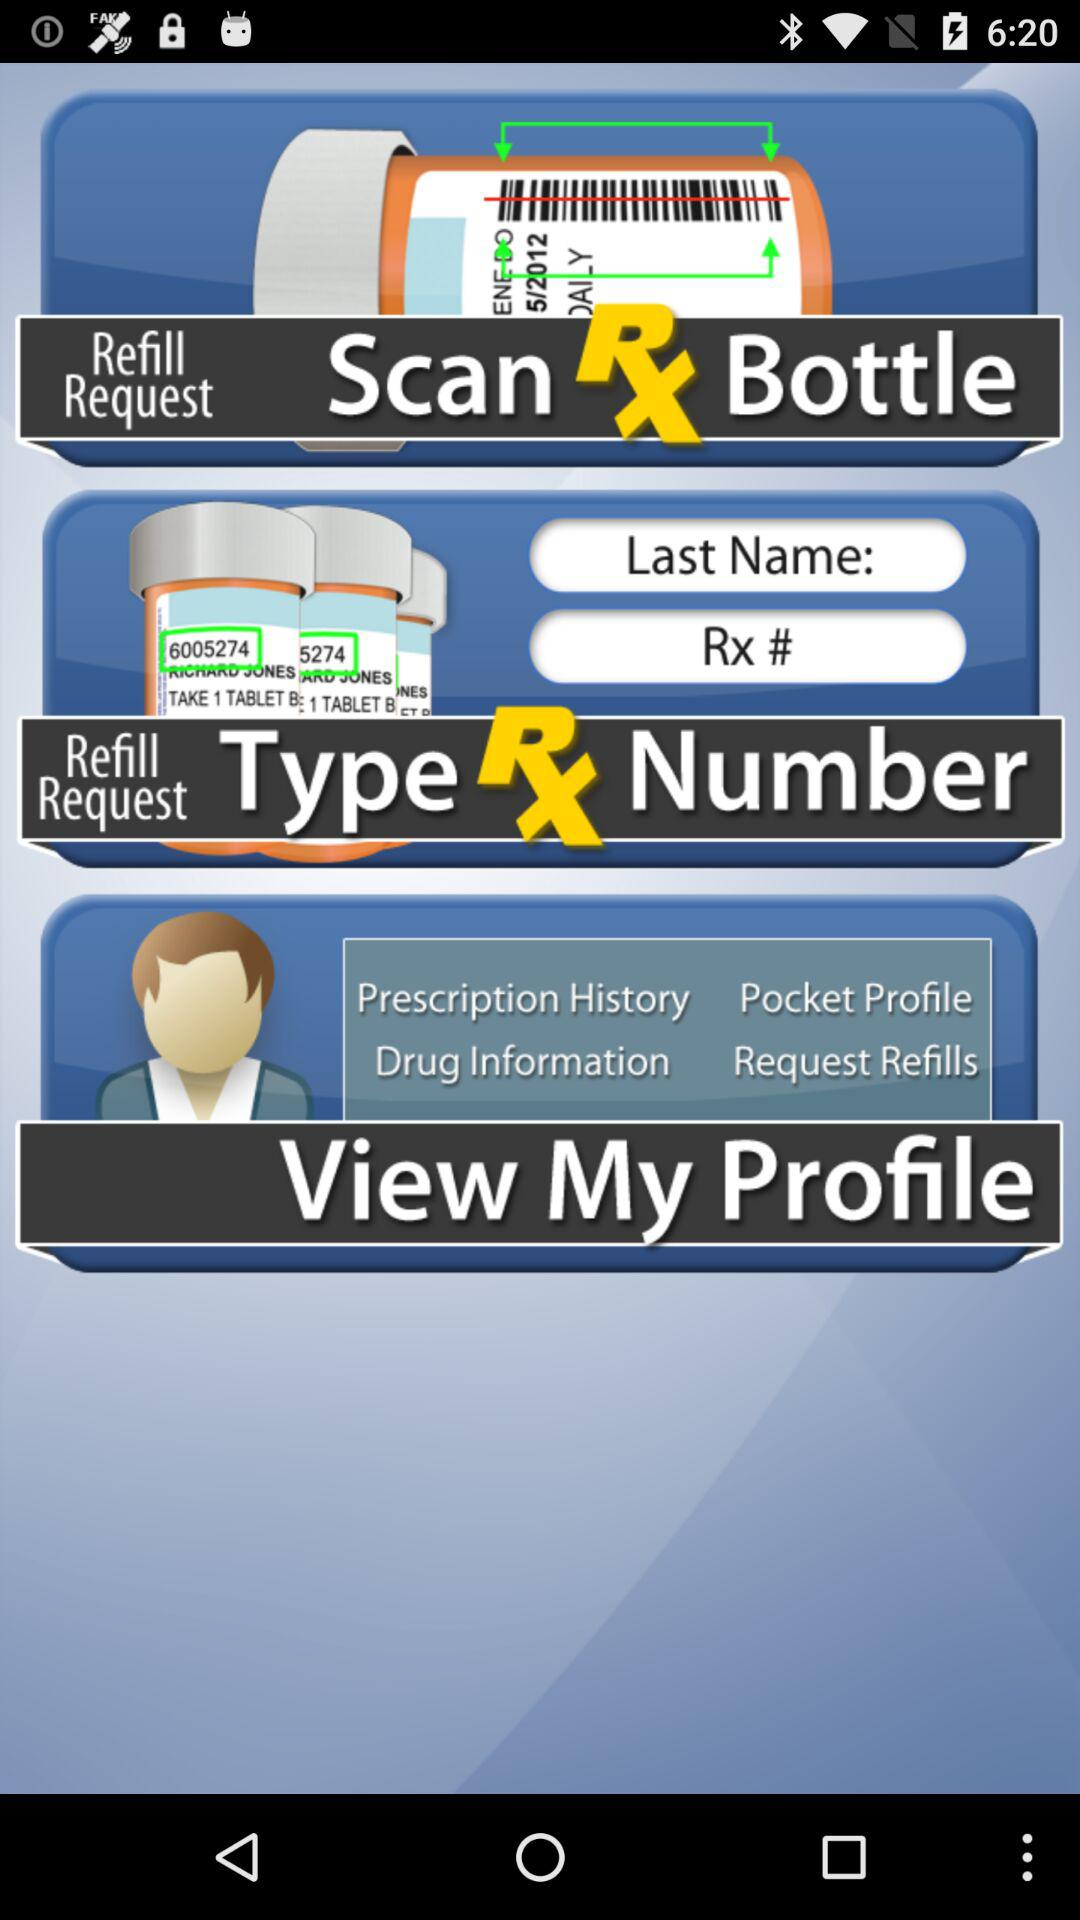What steps to follow to fulfill the refill request?
When the provided information is insufficient, respond with <no answer>. <no answer> 